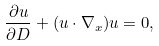<formula> <loc_0><loc_0><loc_500><loc_500>\frac { \partial u } { \partial D } + ( u \cdot \nabla _ { x } ) u = 0 ,</formula> 